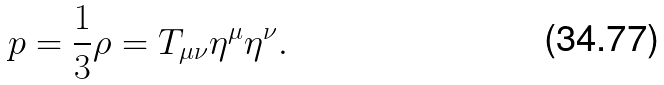<formula> <loc_0><loc_0><loc_500><loc_500>p = \frac { 1 } { 3 } \rho = T _ { \mu \nu } \eta ^ { \mu } \eta ^ { \nu } .</formula> 